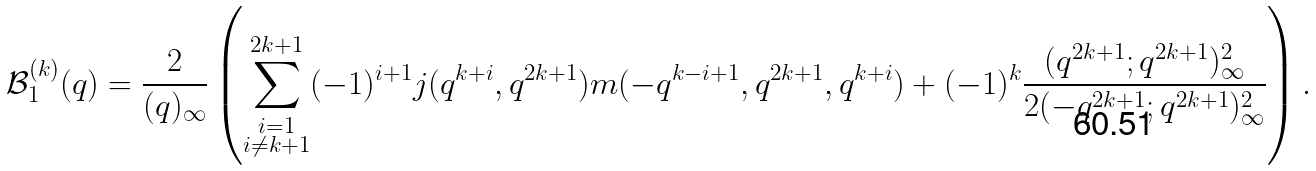<formula> <loc_0><loc_0><loc_500><loc_500>\mathcal { B } _ { 1 } ^ { ( k ) } ( q ) = \frac { 2 } { ( q ) _ { \infty } } \left ( \sum _ { \substack { i = 1 \\ i \neq k + 1 } } ^ { 2 k + 1 } ( - 1 ) ^ { i + 1 } j ( q ^ { k + i } , q ^ { 2 k + 1 } ) m ( - q ^ { k - i + 1 } , q ^ { 2 k + 1 } , q ^ { k + i } ) + ( - 1 ) ^ { k } \frac { ( q ^ { 2 k + 1 } ; q ^ { 2 k + 1 } ) _ { \infty } ^ { 2 } } { 2 ( - q ^ { 2 k + 1 } ; q ^ { 2 k + 1 } ) _ { \infty } ^ { 2 } } \right ) .</formula> 